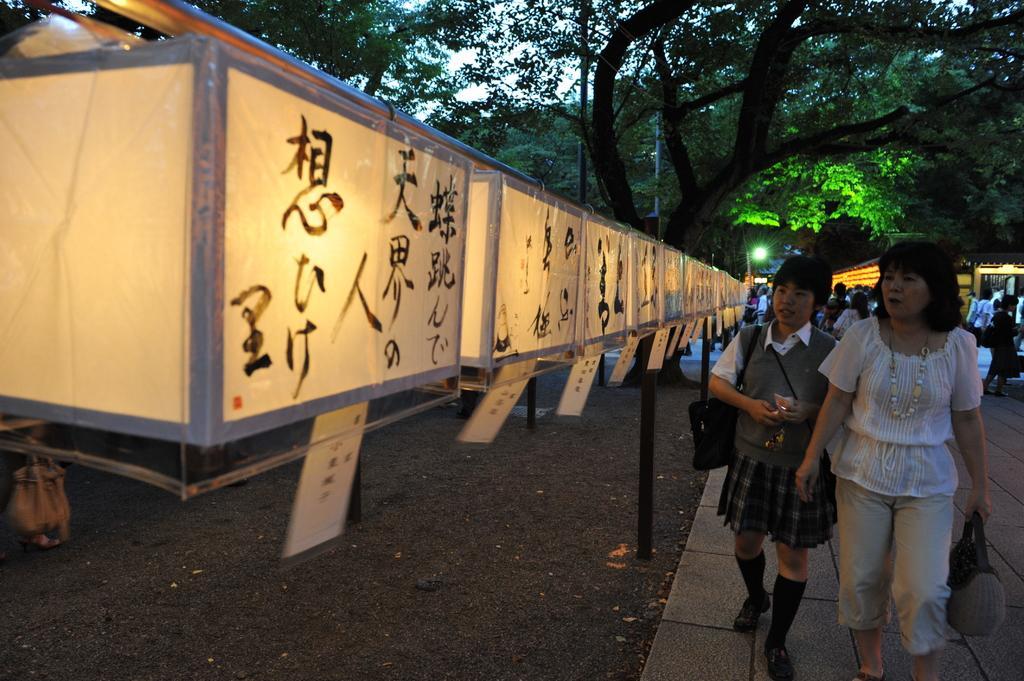How would you summarize this image in a sentence or two? In this image, we can see two persons wearing clothes and walking beside boxes contains lights. There is a tree at the top of the image. 